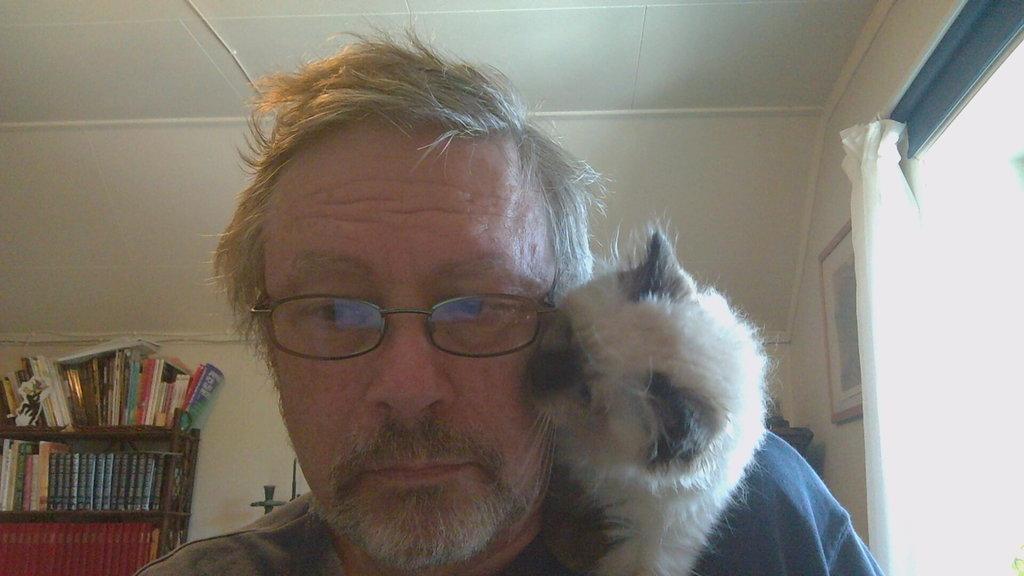How would you summarize this image in a sentence or two? In the middle there is a man he is wearing spectacles and he is wearing a t shirt. In the right there is a curtain and there is a photo frame. On the left there is a book shelves on that there are many books. In the middle there is a wall. In the right there is a animal. 